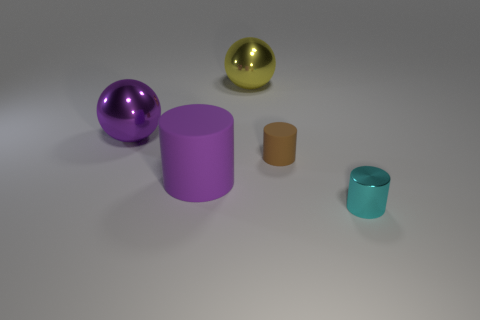Subtract all green spheres. Subtract all red cubes. How many spheres are left? 2 Subtract all brown spheres. How many cyan cylinders are left? 1 Add 5 things. How many tiny purples exist? 0 Subtract all large yellow balls. Subtract all big balls. How many objects are left? 2 Add 4 big balls. How many big balls are left? 6 Add 1 brown cylinders. How many brown cylinders exist? 2 Add 3 small cyan rubber objects. How many objects exist? 8 Subtract all purple cylinders. How many cylinders are left? 2 Subtract all cyan metal cylinders. How many cylinders are left? 2 Subtract 0 cyan cubes. How many objects are left? 5 